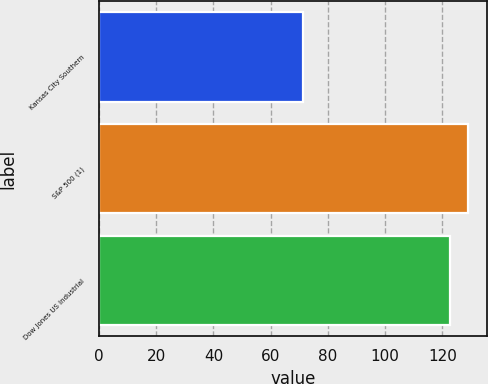Convert chart. <chart><loc_0><loc_0><loc_500><loc_500><bar_chart><fcel>Kansas City Southern<fcel>S&P 500 (1)<fcel>Dow Jones US Industrial<nl><fcel>71.28<fcel>129.05<fcel>122.67<nl></chart> 